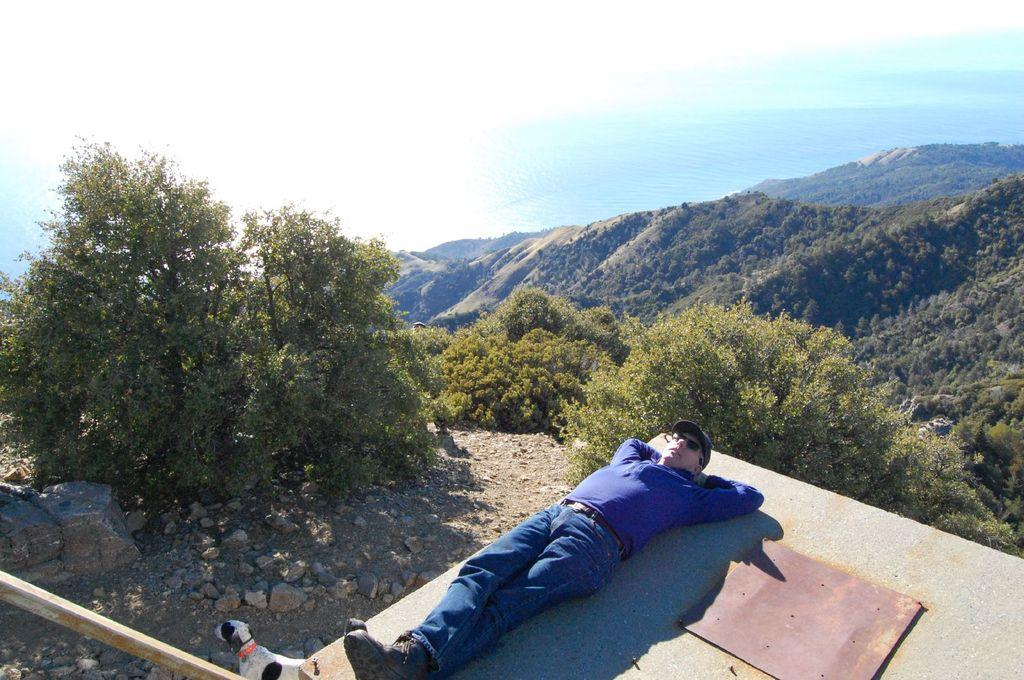What is the main subject of the image? There is a person in the image. What is the person wearing on their head? The person is wearing a cap. What is the person's position in the image? The person is lying on a surface. What type of natural scenery can be seen in the image? There are trees and mountains visible in the image. Are there any animals present in the image? Yes, there is a dog on the surface. What type of skin condition can be seen on the person's face in the image? There is no indication of any skin condition on the person's face in the image. What type of flowers are growing near the trees in the image? There are no flowers visible in the image; only trees and mountains can be seen. 